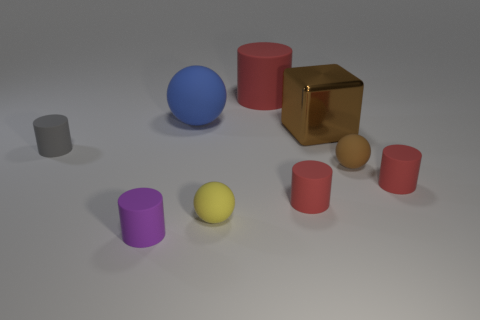Does the large cylinder have the same color as the block?
Keep it short and to the point. No. The ball on the right side of the red object behind the large blue thing is made of what material?
Offer a terse response. Rubber. What material is the large object that is the same shape as the small gray rubber thing?
Offer a terse response. Rubber. There is a object that is right of the tiny rubber sphere behind the yellow rubber thing; are there any yellow rubber objects that are behind it?
Your answer should be compact. No. What number of other objects are there of the same color as the big metal cube?
Offer a terse response. 1. How many small matte cylinders are both to the right of the brown matte thing and on the left side of the big red cylinder?
Give a very brief answer. 0. What is the shape of the metallic thing?
Your answer should be very brief. Cube. How many other things are made of the same material as the small brown thing?
Your answer should be very brief. 7. There is a rubber cylinder that is behind the big rubber object that is left of the large object that is behind the blue ball; what is its color?
Your answer should be compact. Red. There is a red object that is the same size as the brown metal cube; what is its material?
Offer a terse response. Rubber. 